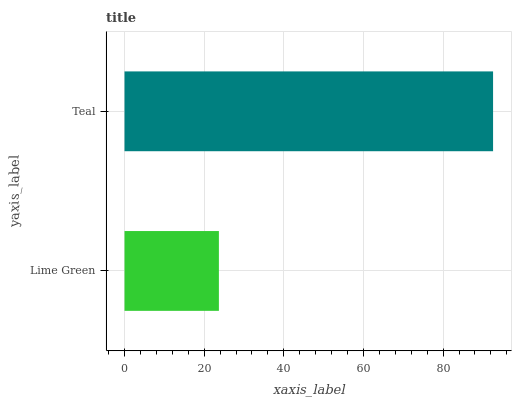Is Lime Green the minimum?
Answer yes or no. Yes. Is Teal the maximum?
Answer yes or no. Yes. Is Teal the minimum?
Answer yes or no. No. Is Teal greater than Lime Green?
Answer yes or no. Yes. Is Lime Green less than Teal?
Answer yes or no. Yes. Is Lime Green greater than Teal?
Answer yes or no. No. Is Teal less than Lime Green?
Answer yes or no. No. Is Teal the high median?
Answer yes or no. Yes. Is Lime Green the low median?
Answer yes or no. Yes. Is Lime Green the high median?
Answer yes or no. No. Is Teal the low median?
Answer yes or no. No. 